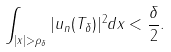<formula> <loc_0><loc_0><loc_500><loc_500>\int _ { | x | > \rho _ { \delta } } | u _ { n } ( T _ { \delta } ) | ^ { 2 } d x < \frac { \delta } { 2 } .</formula> 